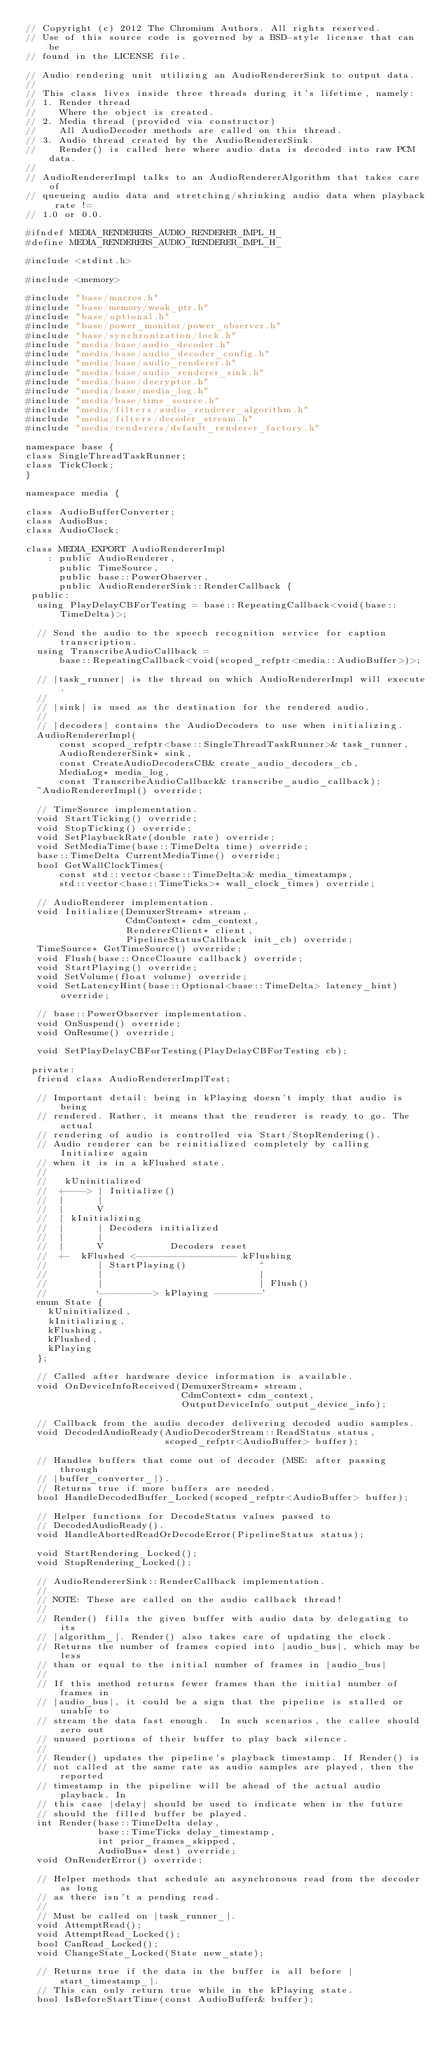<code> <loc_0><loc_0><loc_500><loc_500><_C_>// Copyright (c) 2012 The Chromium Authors. All rights reserved.
// Use of this source code is governed by a BSD-style license that can be
// found in the LICENSE file.

// Audio rendering unit utilizing an AudioRendererSink to output data.
//
// This class lives inside three threads during it's lifetime, namely:
// 1. Render thread
//    Where the object is created.
// 2. Media thread (provided via constructor)
//    All AudioDecoder methods are called on this thread.
// 3. Audio thread created by the AudioRendererSink.
//    Render() is called here where audio data is decoded into raw PCM data.
//
// AudioRendererImpl talks to an AudioRendererAlgorithm that takes care of
// queueing audio data and stretching/shrinking audio data when playback rate !=
// 1.0 or 0.0.

#ifndef MEDIA_RENDERERS_AUDIO_RENDERER_IMPL_H_
#define MEDIA_RENDERERS_AUDIO_RENDERER_IMPL_H_

#include <stdint.h>

#include <memory>

#include "base/macros.h"
#include "base/memory/weak_ptr.h"
#include "base/optional.h"
#include "base/power_monitor/power_observer.h"
#include "base/synchronization/lock.h"
#include "media/base/audio_decoder.h"
#include "media/base/audio_decoder_config.h"
#include "media/base/audio_renderer.h"
#include "media/base/audio_renderer_sink.h"
#include "media/base/decryptor.h"
#include "media/base/media_log.h"
#include "media/base/time_source.h"
#include "media/filters/audio_renderer_algorithm.h"
#include "media/filters/decoder_stream.h"
#include "media/renderers/default_renderer_factory.h"

namespace base {
class SingleThreadTaskRunner;
class TickClock;
}

namespace media {

class AudioBufferConverter;
class AudioBus;
class AudioClock;

class MEDIA_EXPORT AudioRendererImpl
    : public AudioRenderer,
      public TimeSource,
      public base::PowerObserver,
      public AudioRendererSink::RenderCallback {
 public:
  using PlayDelayCBForTesting = base::RepeatingCallback<void(base::TimeDelta)>;

  // Send the audio to the speech recognition service for caption transcription.
  using TranscribeAudioCallback =
      base::RepeatingCallback<void(scoped_refptr<media::AudioBuffer>)>;

  // |task_runner| is the thread on which AudioRendererImpl will execute.
  //
  // |sink| is used as the destination for the rendered audio.
  //
  // |decoders| contains the AudioDecoders to use when initializing.
  AudioRendererImpl(
      const scoped_refptr<base::SingleThreadTaskRunner>& task_runner,
      AudioRendererSink* sink,
      const CreateAudioDecodersCB& create_audio_decoders_cb,
      MediaLog* media_log,
      const TranscribeAudioCallback& transcribe_audio_callback);
  ~AudioRendererImpl() override;

  // TimeSource implementation.
  void StartTicking() override;
  void StopTicking() override;
  void SetPlaybackRate(double rate) override;
  void SetMediaTime(base::TimeDelta time) override;
  base::TimeDelta CurrentMediaTime() override;
  bool GetWallClockTimes(
      const std::vector<base::TimeDelta>& media_timestamps,
      std::vector<base::TimeTicks>* wall_clock_times) override;

  // AudioRenderer implementation.
  void Initialize(DemuxerStream* stream,
                  CdmContext* cdm_context,
                  RendererClient* client,
                  PipelineStatusCallback init_cb) override;
  TimeSource* GetTimeSource() override;
  void Flush(base::OnceClosure callback) override;
  void StartPlaying() override;
  void SetVolume(float volume) override;
  void SetLatencyHint(base::Optional<base::TimeDelta> latency_hint) override;

  // base::PowerObserver implementation.
  void OnSuspend() override;
  void OnResume() override;

  void SetPlayDelayCBForTesting(PlayDelayCBForTesting cb);

 private:
  friend class AudioRendererImplTest;

  // Important detail: being in kPlaying doesn't imply that audio is being
  // rendered. Rather, it means that the renderer is ready to go. The actual
  // rendering of audio is controlled via Start/StopRendering().
  // Audio renderer can be reinitialized completely by calling Initialize again
  // when it is in a kFlushed state.
  //
  //   kUninitialized
  //  +----> | Initialize()
  //  |      |
  //  |      V
  //  | kInitializing
  //  |      | Decoders initialized
  //  |      |
  //  |      V            Decoders reset
  //  +-  kFlushed <------------------ kFlushing
  //         | StartPlaying()             ^
  //         |                            |
  //         |                            | Flush()
  //         `---------> kPlaying --------'
  enum State {
    kUninitialized,
    kInitializing,
    kFlushing,
    kFlushed,
    kPlaying
  };

  // Called after hardware device information is available.
  void OnDeviceInfoReceived(DemuxerStream* stream,
                            CdmContext* cdm_context,
                            OutputDeviceInfo output_device_info);

  // Callback from the audio decoder delivering decoded audio samples.
  void DecodedAudioReady(AudioDecoderStream::ReadStatus status,
                         scoped_refptr<AudioBuffer> buffer);

  // Handles buffers that come out of decoder (MSE: after passing through
  // |buffer_converter_|).
  // Returns true if more buffers are needed.
  bool HandleDecodedBuffer_Locked(scoped_refptr<AudioBuffer> buffer);

  // Helper functions for DecodeStatus values passed to
  // DecodedAudioReady().
  void HandleAbortedReadOrDecodeError(PipelineStatus status);

  void StartRendering_Locked();
  void StopRendering_Locked();

  // AudioRendererSink::RenderCallback implementation.
  //
  // NOTE: These are called on the audio callback thread!
  //
  // Render() fills the given buffer with audio data by delegating to its
  // |algorithm_|. Render() also takes care of updating the clock.
  // Returns the number of frames copied into |audio_bus|, which may be less
  // than or equal to the initial number of frames in |audio_bus|
  //
  // If this method returns fewer frames than the initial number of frames in
  // |audio_bus|, it could be a sign that the pipeline is stalled or unable to
  // stream the data fast enough.  In such scenarios, the callee should zero out
  // unused portions of their buffer to play back silence.
  //
  // Render() updates the pipeline's playback timestamp. If Render() is
  // not called at the same rate as audio samples are played, then the reported
  // timestamp in the pipeline will be ahead of the actual audio playback. In
  // this case |delay| should be used to indicate when in the future
  // should the filled buffer be played.
  int Render(base::TimeDelta delay,
             base::TimeTicks delay_timestamp,
             int prior_frames_skipped,
             AudioBus* dest) override;
  void OnRenderError() override;

  // Helper methods that schedule an asynchronous read from the decoder as long
  // as there isn't a pending read.
  //
  // Must be called on |task_runner_|.
  void AttemptRead();
  void AttemptRead_Locked();
  bool CanRead_Locked();
  void ChangeState_Locked(State new_state);

  // Returns true if the data in the buffer is all before |start_timestamp_|.
  // This can only return true while in the kPlaying state.
  bool IsBeforeStartTime(const AudioBuffer& buffer);
</code> 